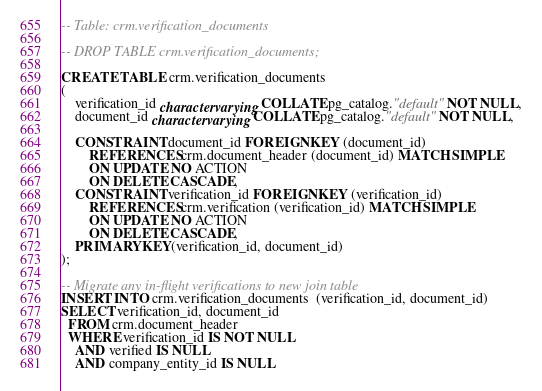Convert code to text. <code><loc_0><loc_0><loc_500><loc_500><_SQL_>-- Table: crm.verification_documents

-- DROP TABLE crm.verification_documents;

CREATE TABLE crm.verification_documents
(
    verification_id character varying COLLATE pg_catalog."default" NOT NULL,
    document_id character varying COLLATE pg_catalog."default" NOT NULL,

    CONSTRAINT document_id FOREIGN KEY (document_id)
        REFERENCES crm.document_header (document_id) MATCH SIMPLE
        ON UPDATE NO ACTION
        ON DELETE CASCADE,
    CONSTRAINT verification_id FOREIGN KEY (verification_id)
        REFERENCES crm.verification (verification_id) MATCH SIMPLE
        ON UPDATE NO ACTION
        ON DELETE CASCADE,
    PRIMARY KEY(verification_id, document_id)
);

-- Migrate any in-flight verifications to new join table
INSERT INTO crm.verification_documents  (verification_id, document_id)
SELECT verification_id, document_id
  FROM crm.document_header
  WHERE verification_id IS NOT NULL
    AND verified IS NULL
    AND company_entity_id IS NULL
</code> 